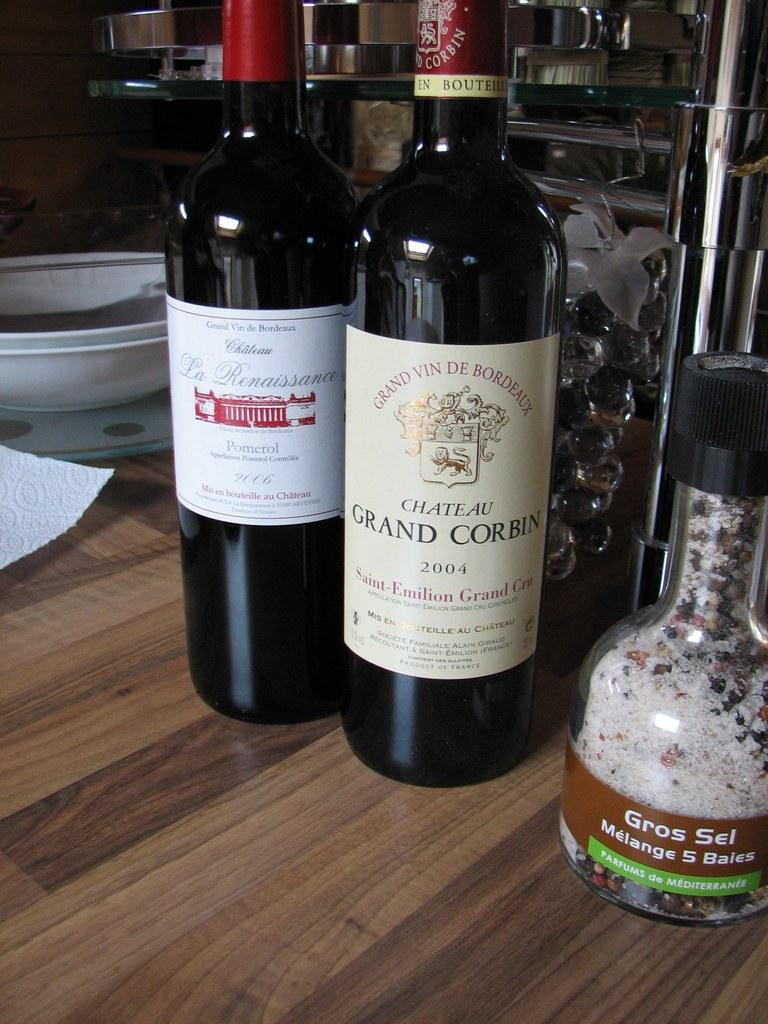<image>
Summarize the visual content of the image. A bottle of Chateau Gran Corbin fro 2004 sits on a wooden table next to another bottle of wine. 